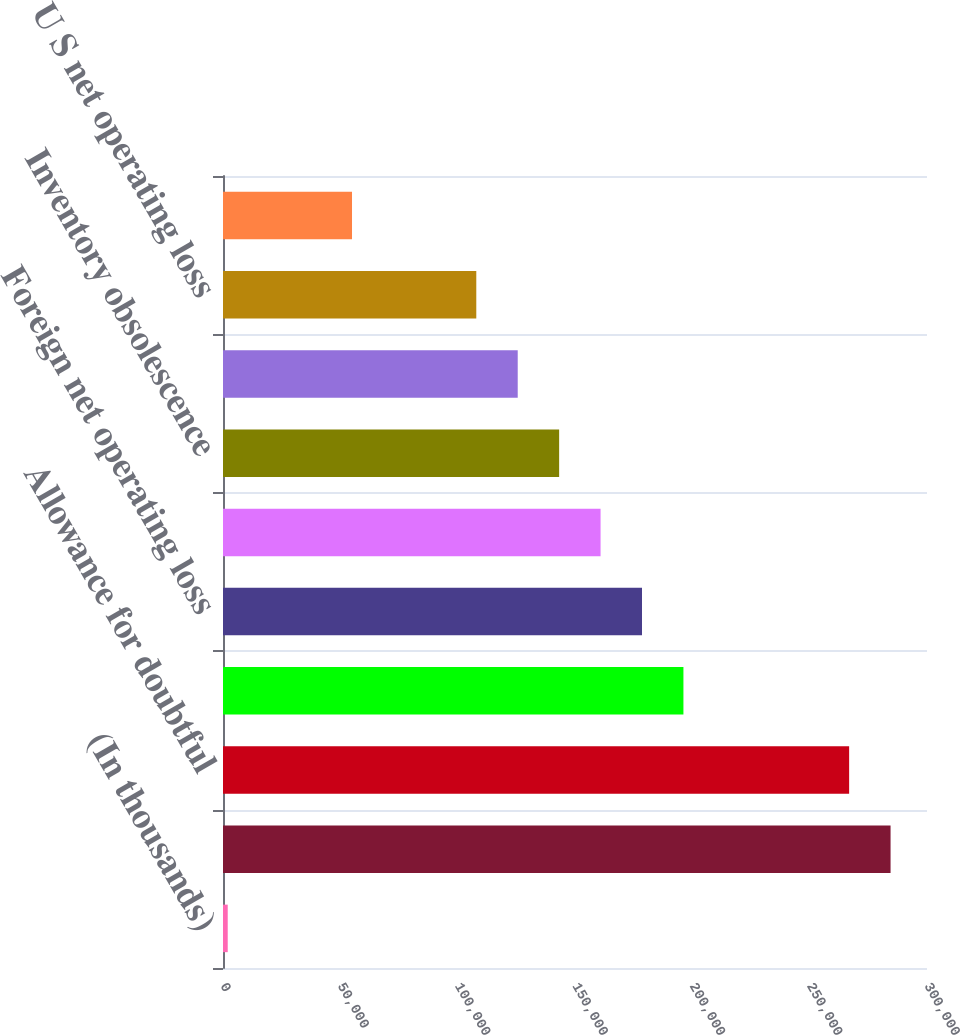Convert chart to OTSL. <chart><loc_0><loc_0><loc_500><loc_500><bar_chart><fcel>(In thousands)<fcel>Stock-based compensation<fcel>Allowance for doubtful<fcel>Accrued expenses<fcel>Foreign net operating loss<fcel>Deferred rent<fcel>Inventory obsolescence<fcel>Tax basis inventory adjustment<fcel>U S net operating loss<fcel>Foreign tax credits<nl><fcel>2015<fcel>284474<fcel>266820<fcel>196206<fcel>178552<fcel>160898<fcel>143245<fcel>125591<fcel>107937<fcel>54976.1<nl></chart> 